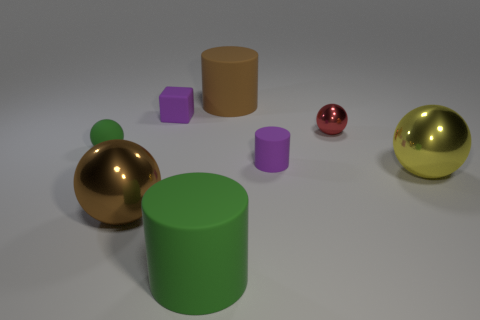Subtract all big brown cylinders. How many cylinders are left? 2 Add 1 large yellow metallic objects. How many objects exist? 9 Subtract 1 cubes. How many cubes are left? 0 Subtract all yellow balls. How many balls are left? 3 Add 5 tiny green things. How many tiny green things exist? 6 Subtract 0 cyan balls. How many objects are left? 8 Subtract all blocks. How many objects are left? 7 Subtract all blue cylinders. Subtract all purple blocks. How many cylinders are left? 3 Subtract all yellow cylinders. How many brown cubes are left? 0 Subtract all green metal things. Subtract all metallic objects. How many objects are left? 5 